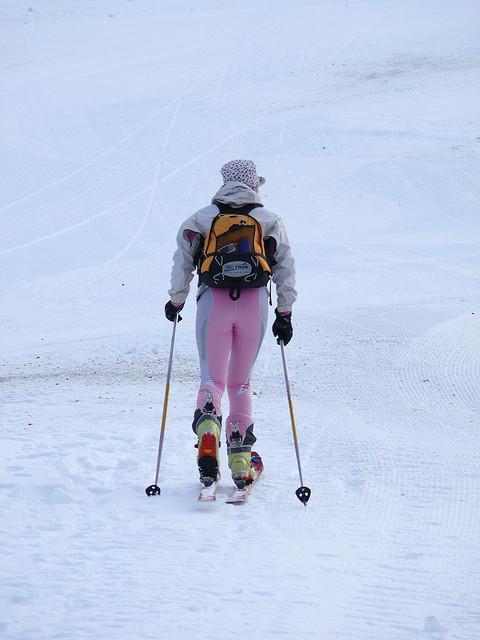How many people seen?
Give a very brief answer. 1. How many birds stand on the sand?
Give a very brief answer. 0. 